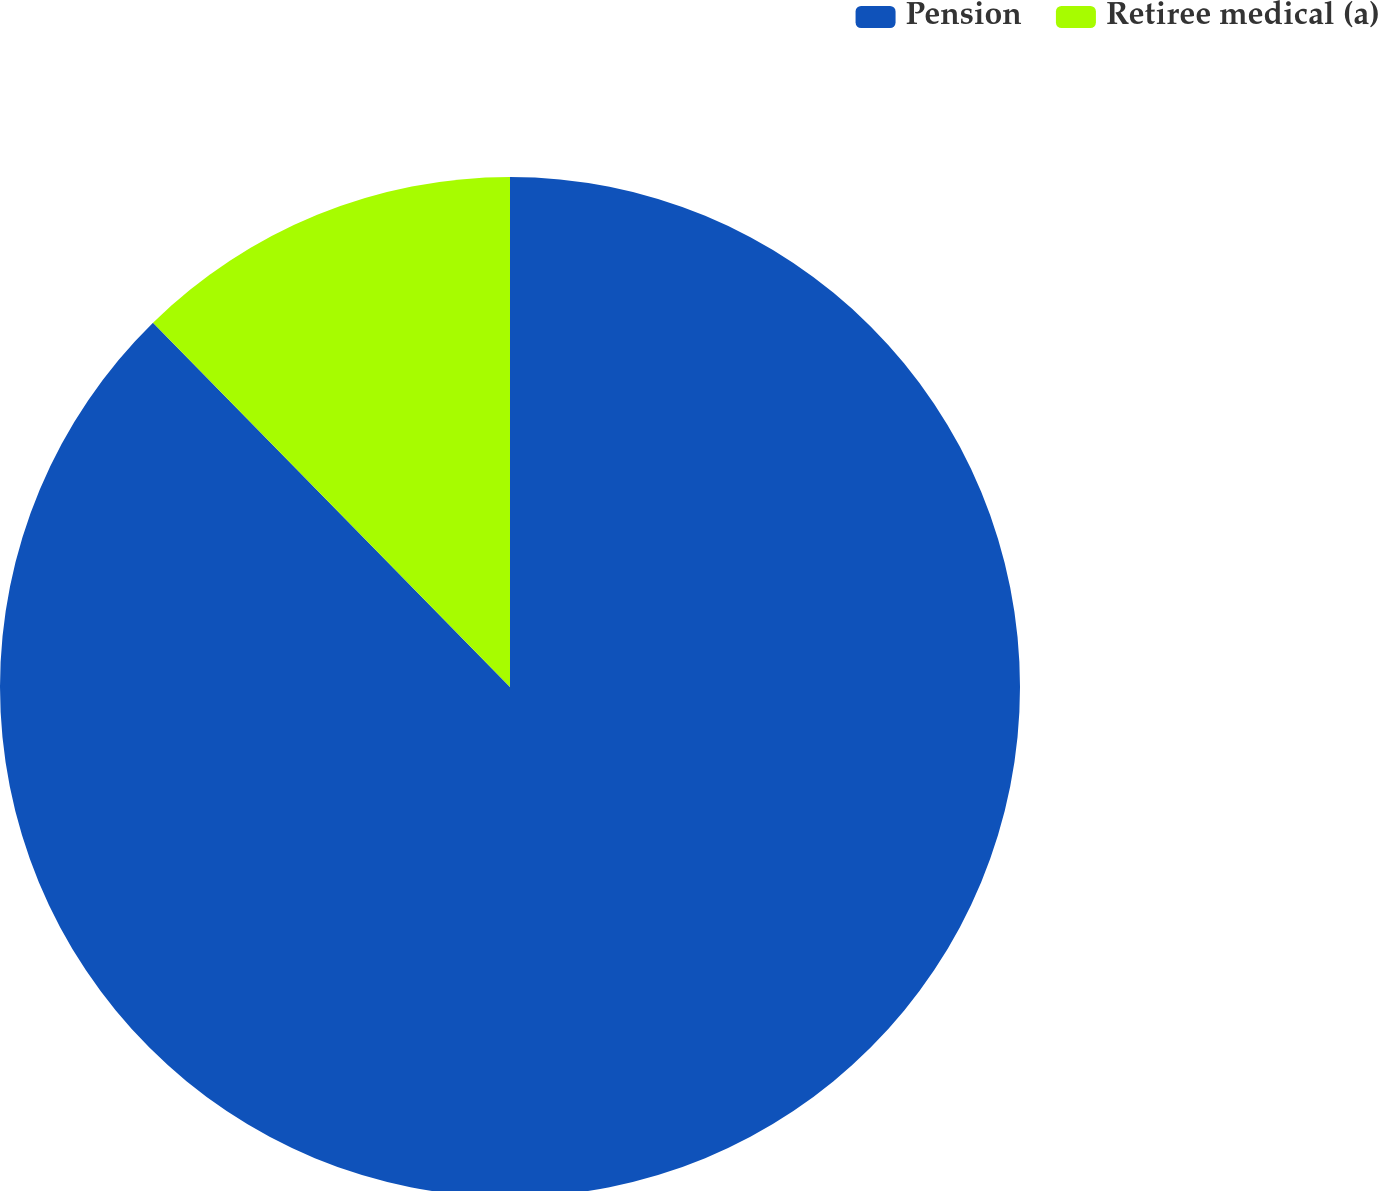<chart> <loc_0><loc_0><loc_500><loc_500><pie_chart><fcel>Pension<fcel>Retiree medical (a)<nl><fcel>87.66%<fcel>12.34%<nl></chart> 